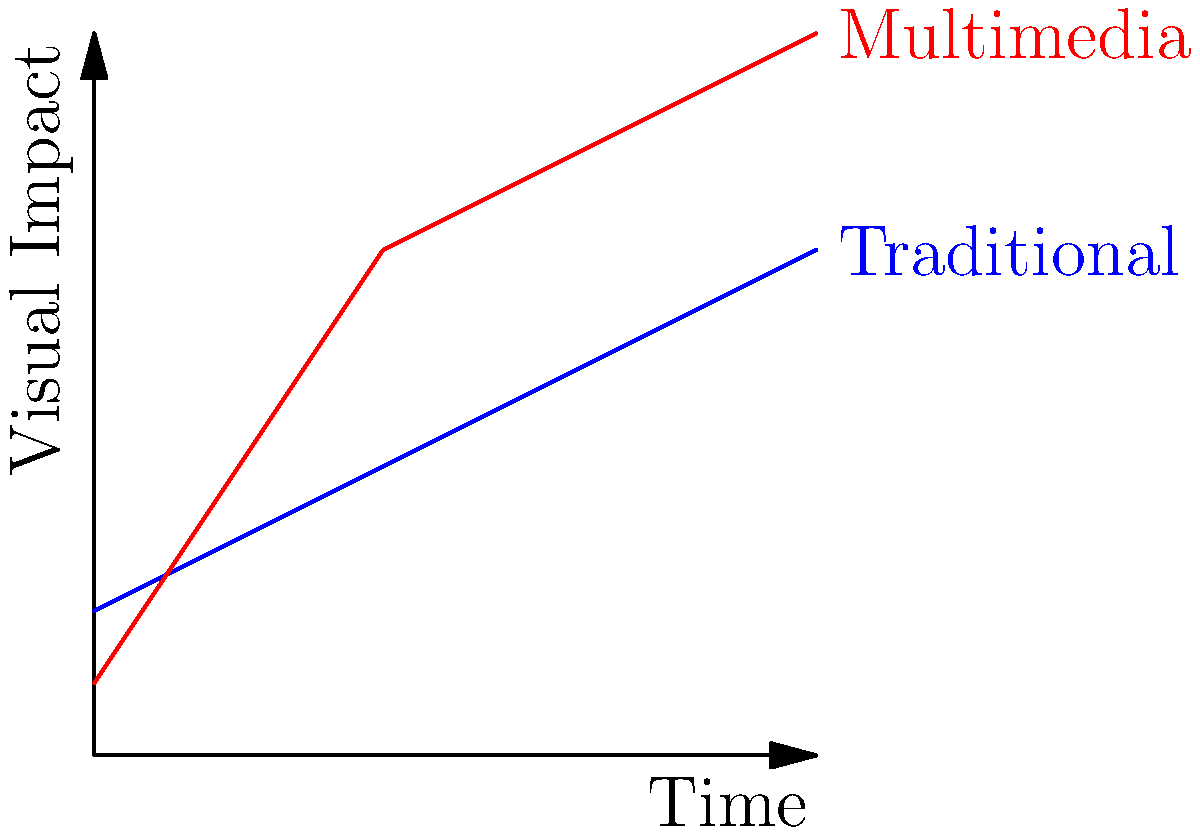Based on the graph showing the visual impact of traditional vs. multimedia opening credits over time, at which point (in seconds) does the multimedia approach start to outperform the traditional method in terms of visual impact? To determine when the multimedia approach starts to outperform the traditional method, we need to follow these steps:

1. Identify the two lines on the graph:
   - Blue line represents the traditional approach
   - Red line represents the multimedia approach

2. Find the intersection point of these two lines:
   - This is where the multimedia approach begins to have a higher visual impact than the traditional approach

3. Analyze the graph:
   - At t = 0 seconds, traditional approach has higher impact
   - The lines intersect between t = 2 and t = 4 seconds

4. Estimate the precise intersection point:
   - It appears to be closer to t = 3 seconds

5. Verify the result:
   - Before t = 3 seconds, the blue line (traditional) is higher
   - After t = 3 seconds, the red line (multimedia) is higher

Therefore, the multimedia approach starts to outperform the traditional method at approximately 3 seconds into the opening credits sequence.
Answer: 3 seconds 